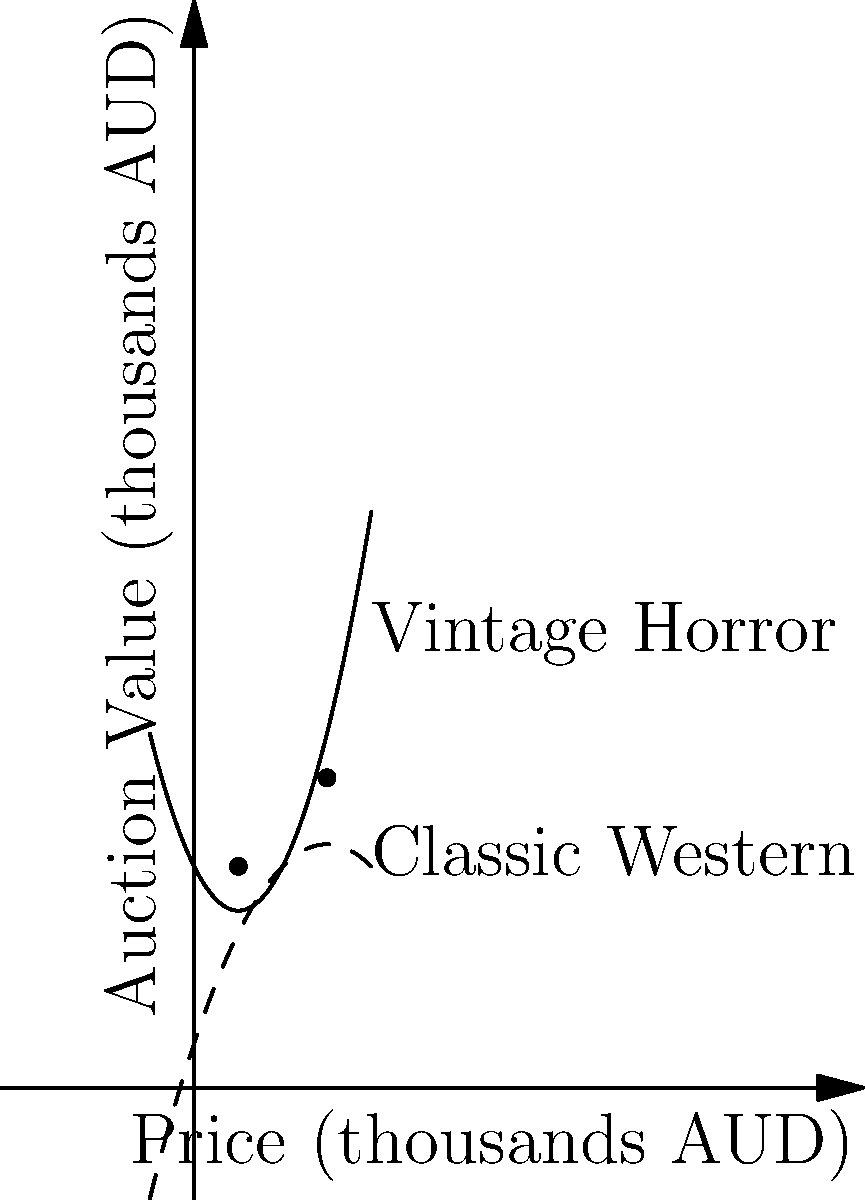The graph shows the auction value trends for two rare film reels: a vintage horror film (solid curve) and a classic western (dashed curve). The curves are represented by the polynomials $f(x) = 0.5x^2 - 2x + 10$ and $g(x) = -0.25x^2 + 3x + 2$, where $x$ is the price in thousands of Australian dollars (AUD). At what two prices do these film reels have the same auction value, and what is that value at the higher price point? To find the intersection points, we need to solve the equation $f(x) = g(x)$:

1) $0.5x^2 - 2x + 10 = -0.25x^2 + 3x + 2$

2) Rearranging terms: $0.75x^2 - 5x + 8 = 0$

3) This is a quadratic equation. We can solve it using the quadratic formula:
   $x = \frac{-b \pm \sqrt{b^2 - 4ac}}{2a}$, where $a=0.75$, $b=-5$, and $c=8$

4) Substituting these values:
   $x = \frac{5 \pm \sqrt{25 - 4(0.75)(8)}}{2(0.75)} = \frac{5 \pm \sqrt{25 - 24}}{1.5} = \frac{5 \pm 1}{1.5}$

5) This gives us two solutions: $x_1 = 2$ and $x_2 = 6$

6) To find the auction value at the higher price point ($x=6$), we can substitute this into either $f(x)$ or $g(x)$:

   $f(6) = 0.5(6)^2 - 2(6) + 10 = 18 - 12 + 10 = 16$

Therefore, the film reels have the same auction value at 2,000 AUD and 6,000 AUD, with the higher value being 16,000 AUD.
Answer: 2,000 AUD and 6,000 AUD; 16,000 AUD 